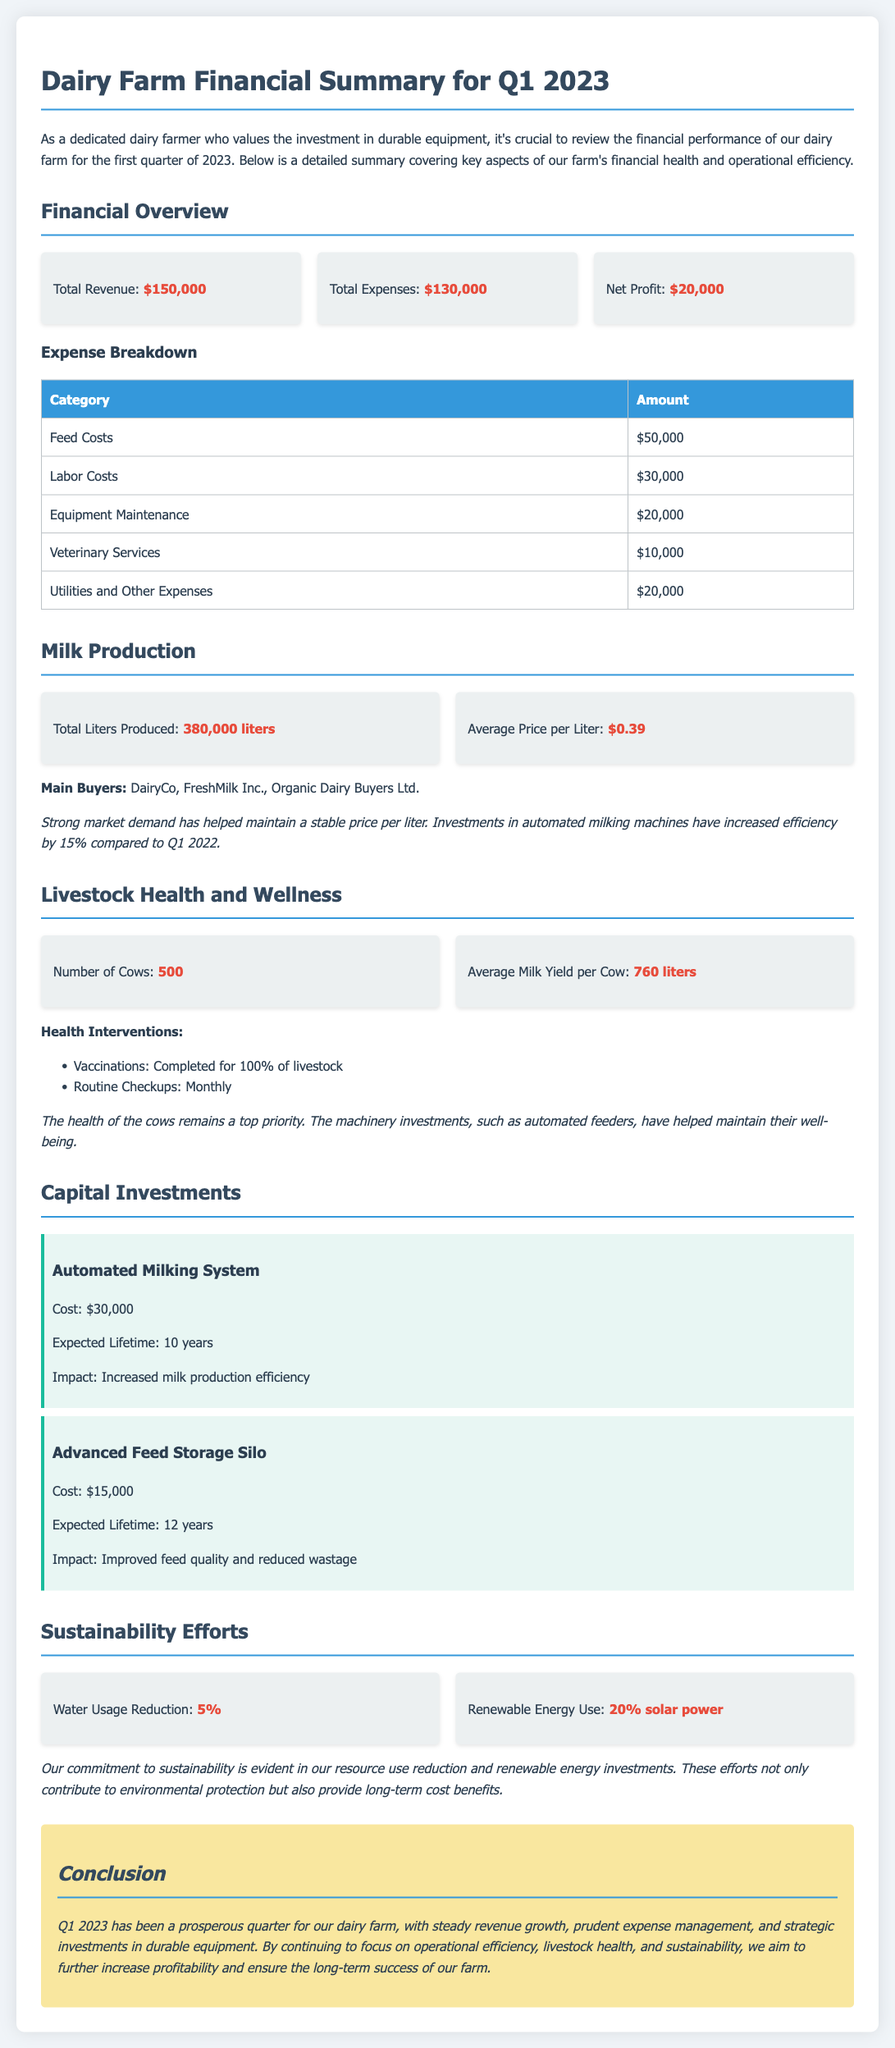What is the total revenue? The total revenue is stated directly in the financial overview section of the document.
Answer: $150,000 What is the net profit? The net profit is calculated from the total revenue minus total expenses, which is mentioned in the financial overview.
Answer: $20,000 How many liters of milk were produced? This information is provided under the milk production section.
Answer: 380,000 liters What is the average price per liter? The average price per liter is listed in the milk production section of the document.
Answer: $0.39 How many cows are on the farm? The number of cows is detailed in the livestock health and wellness section.
Answer: 500 What was the cost of the automated milking system? The cost of the automated milking system is mentioned in the capital investments section.
Answer: $30,000 What percentage of energy use is renewable? The renewable energy usage is outlined in the sustainability efforts section of the document.
Answer: 20% solar power What was spent on labor costs? Labor costs are one of the expense breakdown categories listed in the document.
Answer: $30,000 What health interventions were completed for the livestock? The document states interventions completed, specifically vaccinations.
Answer: 100% of livestock 